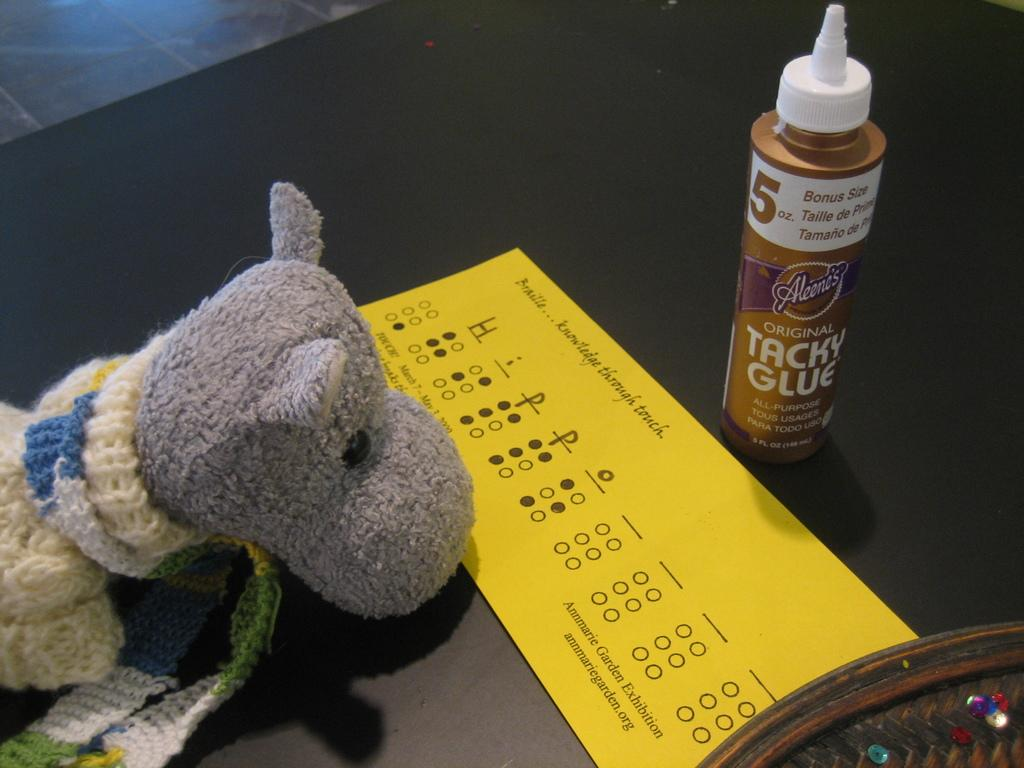<image>
Write a terse but informative summary of the picture. A can of Tacky Glue stands next to a yellow Braille test form. 